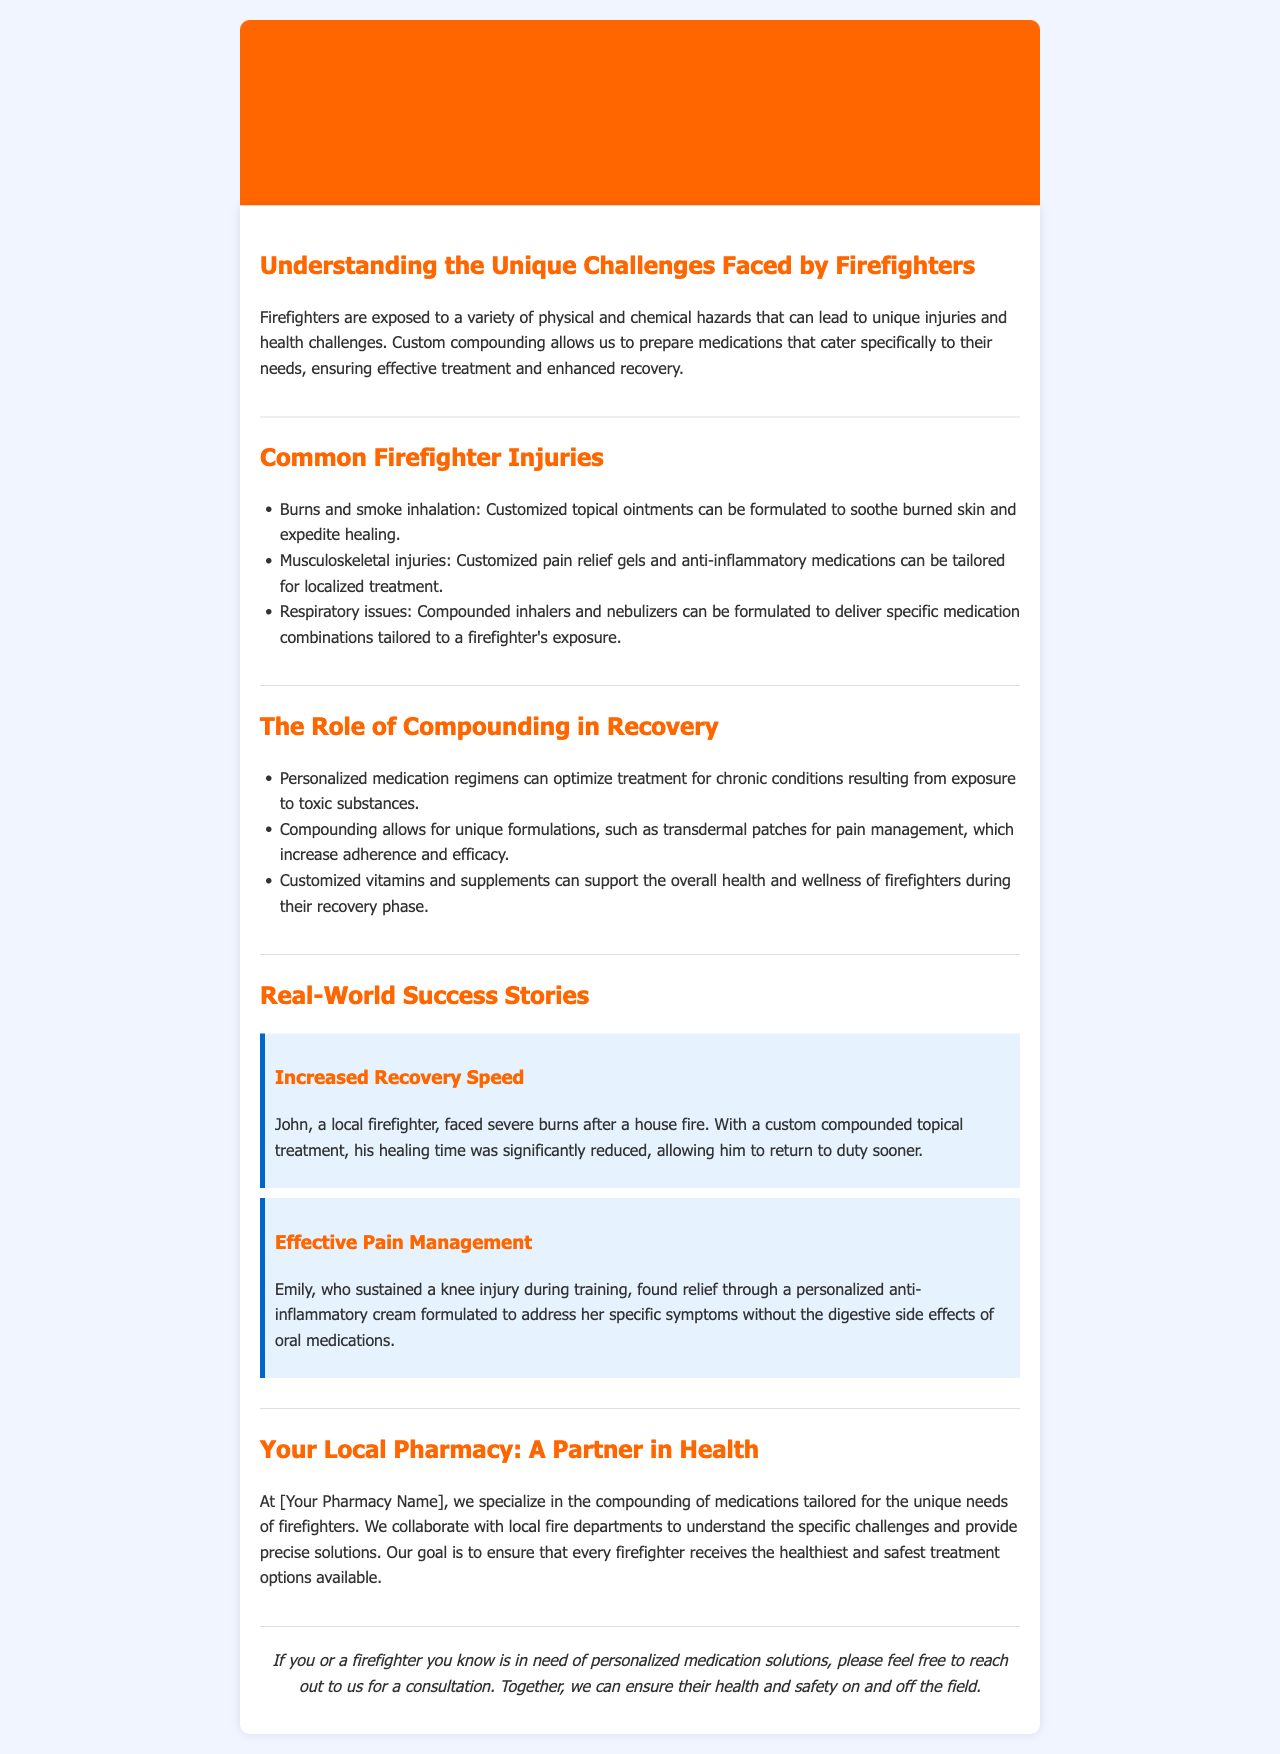What are the unique challenges faced by firefighters? The unique challenges faced by firefighters include a variety of physical and chemical hazards that can lead to injuries and health challenges.
Answer: Physical and chemical hazards What is one common firefighter injury mentioned? The document lists several common firefighter injuries, one of which is burns and smoke inhalation.
Answer: Burns and smoke inhalation Which personalized treatment is mentioned for musculoskeletal injuries? The newsletter specifies that customized pain relief gels can be tailored for localized treatment of musculoskeletal injuries.
Answer: Pain relief gels What is the outcome of using custom compounded topical treatment for burns? The document states that a local firefighter named John saw a significantly reduced healing time thanks to the custom treatment.
Answer: Significantly reduced healing time What kind of cream helped Emily manage her injury? The document mentions that Emily found relief through a personalized anti-inflammatory cream.
Answer: Anti-inflammatory cream What kind of health support is provided in customized medications? The document indicates that customized vitamins and supplements can support overall health and wellness during recovery.
Answer: Vitamins and supplements What is the goal of your local pharmacy according to the newsletter? The document states that the goal is to ensure that every firefighter receives the healthiest and safest treatment options available.
Answer: Healthiest and safest treatment options Who collaborated with the local pharmacy to understand challenges? The newsletter mentions that the pharmacy collaborates with local fire departments to understand specific challenges.
Answer: Local fire departments 